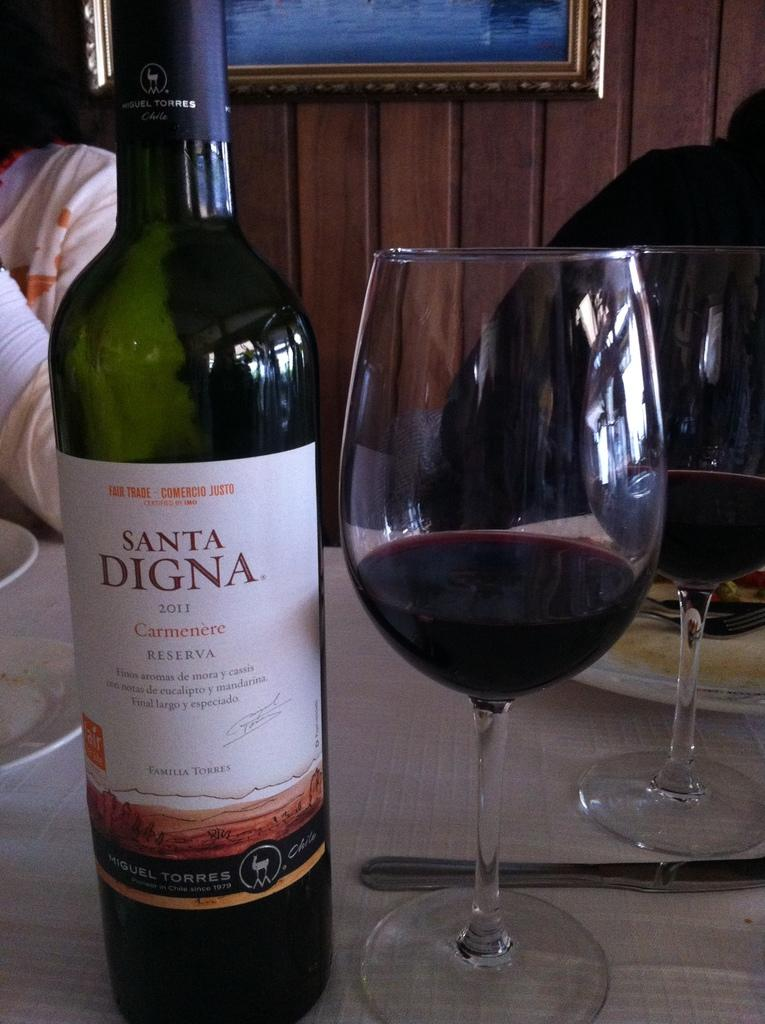<image>
Render a clear and concise summary of the photo. A bottle of Santa Digna wine is on a white table next to a glass of red wine. 